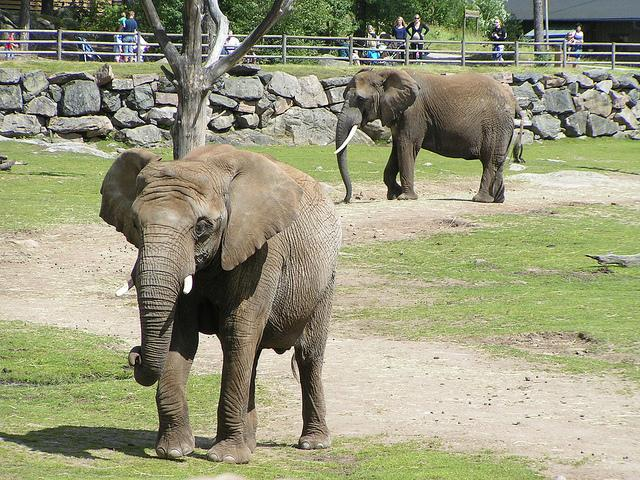At which elevation are the elephants compared to those looking at them? Please explain your reasoning. lower. The people are behind a fence which has a drop and a stone wall  showing them higher than the elephants. 